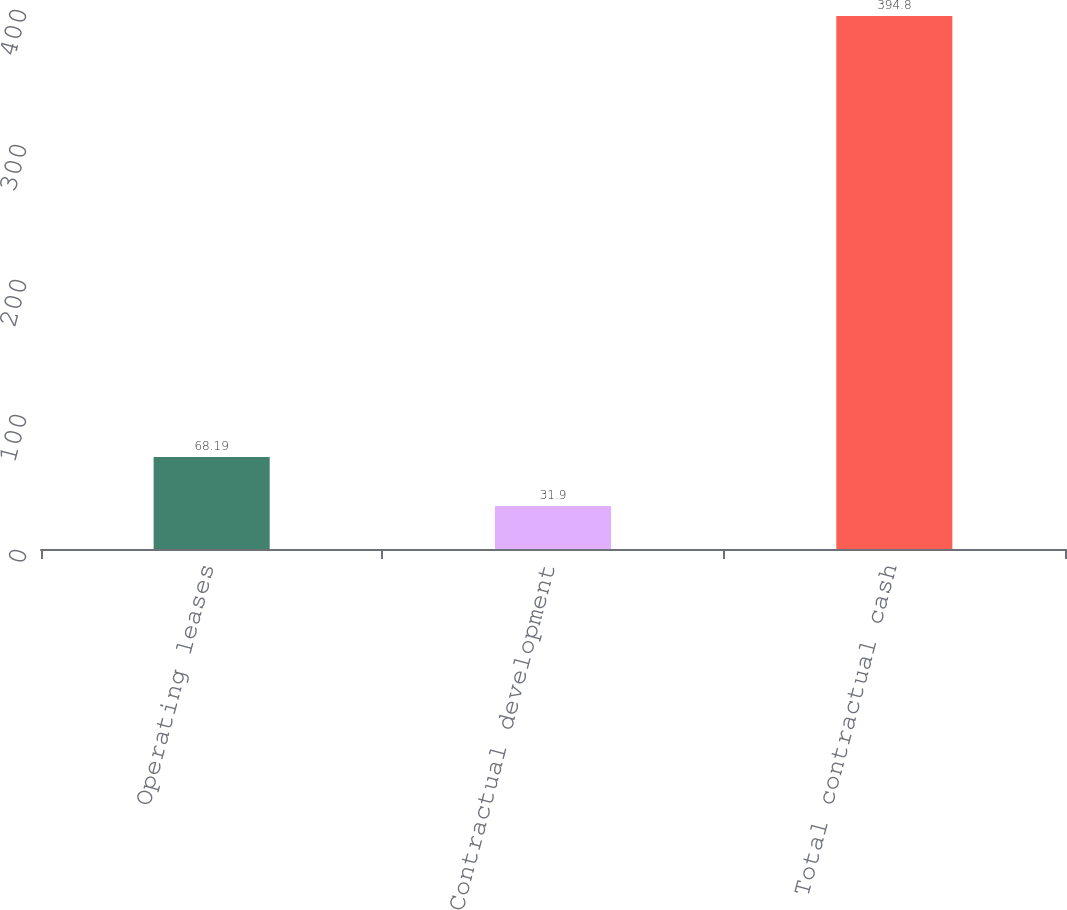Convert chart to OTSL. <chart><loc_0><loc_0><loc_500><loc_500><bar_chart><fcel>Operating leases<fcel>Contractual development<fcel>Total contractual cash<nl><fcel>68.19<fcel>31.9<fcel>394.8<nl></chart> 